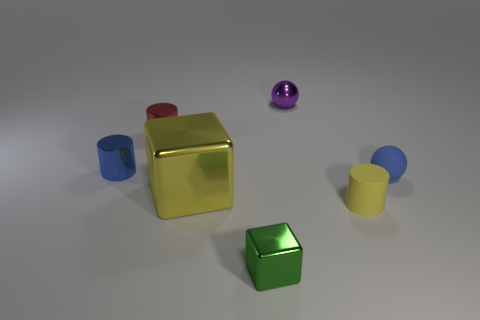What number of rubber things are the same size as the purple shiny ball?
Make the answer very short. 2. What size is the other object that is the same color as the large metallic object?
Keep it short and to the point. Small. Is the tiny metallic sphere the same color as the tiny rubber ball?
Ensure brevity in your answer.  No. The small yellow object has what shape?
Ensure brevity in your answer.  Cylinder. Is there a metallic thing that has the same color as the tiny block?
Your answer should be compact. No. Are there more rubber things that are to the left of the purple object than small gray things?
Provide a succinct answer. No. There is a green object; is its shape the same as the blue thing that is left of the large yellow metal block?
Your answer should be compact. No. Are any small purple metallic things visible?
Provide a short and direct response. Yes. What number of small objects are yellow metal cubes or yellow rubber cylinders?
Offer a terse response. 1. Is the number of yellow matte things right of the small yellow matte thing greater than the number of tiny yellow matte objects left of the tiny red cylinder?
Provide a succinct answer. No. 